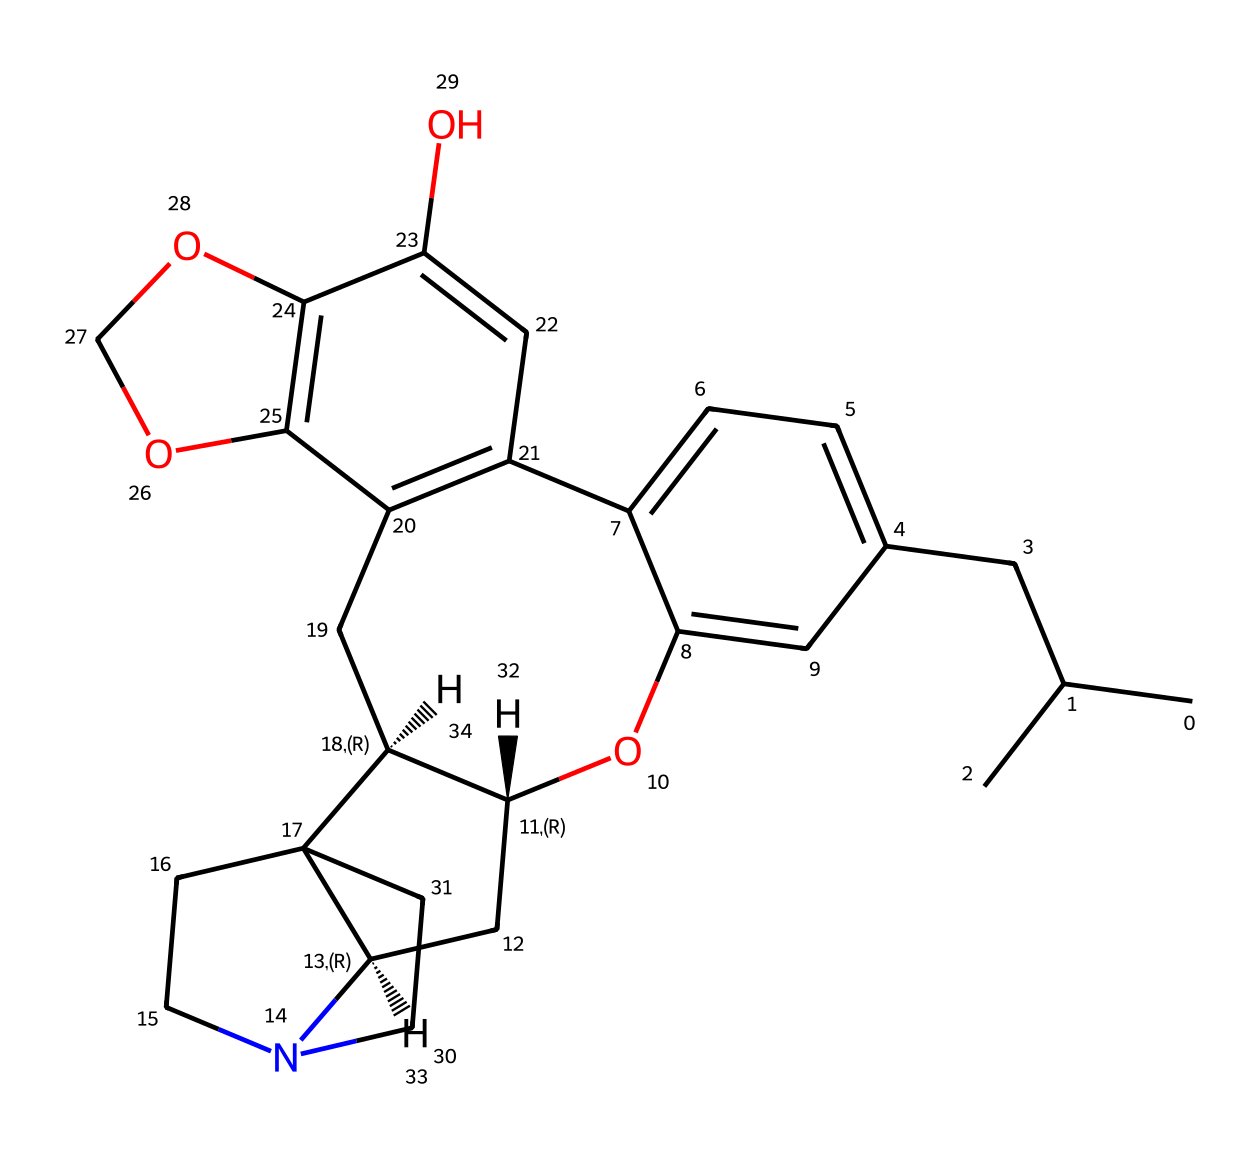How many nitrogen atoms are in this chemical? By examining the structure, we can identify nitrogen atoms, which are commonly represented by 'N'. In this SMILES notation, there are two instances of 'N'.
Answer: 2 What is the molecular formula of this chemical? To determine the molecular formula, we need to count the number of each type of atom based on the SMILES: C, H, O, and N. By analyzing the structure, the formula is found to be C25H31N2O4.
Answer: C25H31N2O4 Is this chemical a natural or synthetic compound? This compound has a complexity and structure akin to synthetic opioids, indicated by its elaborate structure with multiple rings and oxygen functionalities. Therefore, it is likely synthetic.
Answer: synthetic What type of drug is characterized by this chemical structure? This compound contains features typical of opioids, such as a cyclic structure and nitrogen content, which are representative of opioid analgesics.
Answer: opioid What specific functional groups are present in this chemical? By analyzing the structure, we can see that the compound has aromatic rings and hydroxyl (–OH) groups, both of which are critical markers in drugs affecting the central nervous system.
Answer: aromatic and hydroxyl What effect do the nitrogen atoms in this chemical have on its pharmacological properties? The presence of nitrogen in the structure suggests basic properties contributing to receptor binding in the nervous system, crucial in the mechanisms of action for opioids.
Answer: receptor binding 